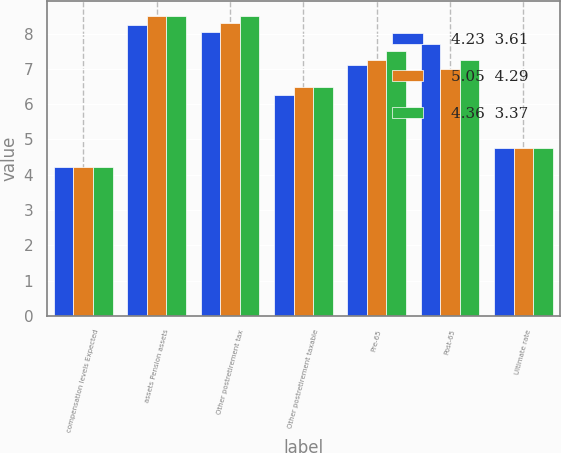<chart> <loc_0><loc_0><loc_500><loc_500><stacked_bar_chart><ecel><fcel>compensation levels Expected<fcel>assets Pension assets<fcel>Other postretirement tax<fcel>Other postretirement taxable<fcel>Pre-65<fcel>Post-65<fcel>Ultimate rate<nl><fcel>4.23  3.61<fcel>4.23<fcel>8.25<fcel>8.05<fcel>6.25<fcel>7.1<fcel>7.7<fcel>4.75<nl><fcel>5.05  4.29<fcel>4.23<fcel>8.5<fcel>8.3<fcel>6.5<fcel>7.25<fcel>7<fcel>4.75<nl><fcel>4.36  3.37<fcel>4.23<fcel>8.5<fcel>8.5<fcel>6.5<fcel>7.5<fcel>7.25<fcel>4.75<nl></chart> 